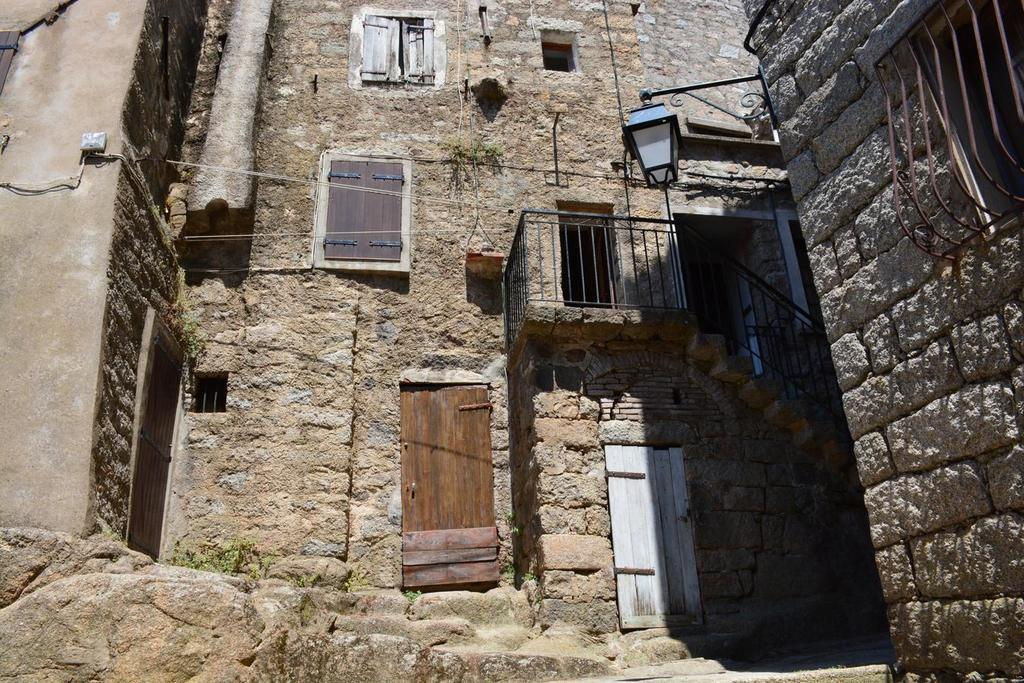What type of structure is visible in the image? There is a building in the image. What are the doors made of in the building? The building has two wooden doors. Are there any openings in the building besides the doors? Yes, the building has windows. What architectural feature can be seen in the right corner of the image? There is a staircase in the right corner of the image. What type of beef is being cooked in the image? There is no beef present in the image; it features a building with wooden doors, windows, and a staircase. How many love letters can be seen on the staircase in the image? There are no love letters visible on the staircase in the image. 